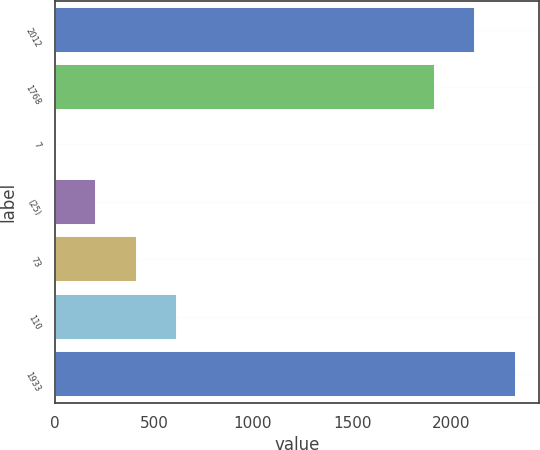Convert chart to OTSL. <chart><loc_0><loc_0><loc_500><loc_500><bar_chart><fcel>2012<fcel>1768<fcel>7<fcel>(25)<fcel>73<fcel>110<fcel>1933<nl><fcel>2121<fcel>1917<fcel>6<fcel>210<fcel>414<fcel>618<fcel>2325<nl></chart> 